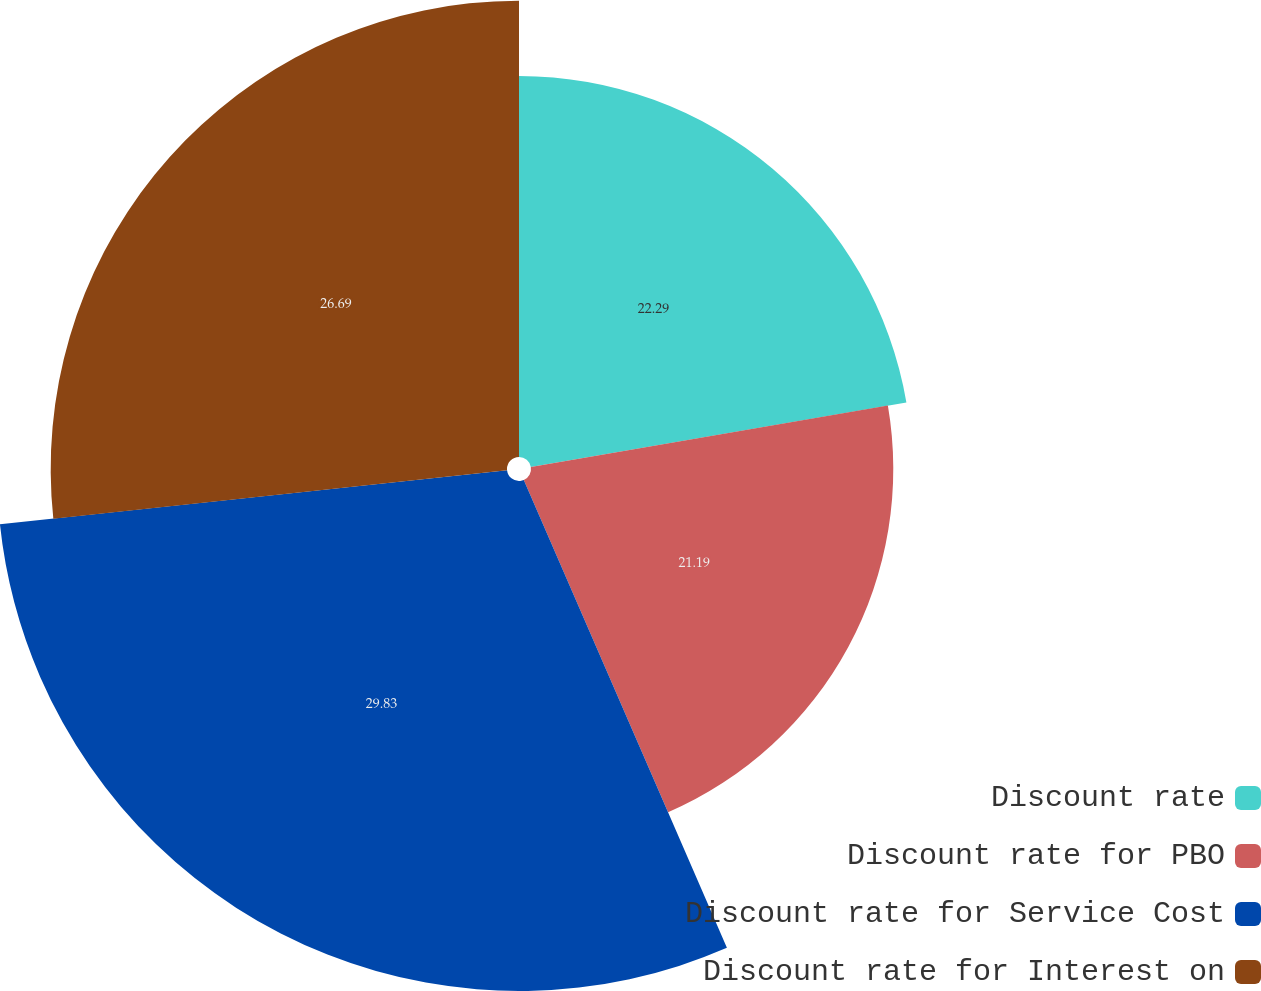Convert chart. <chart><loc_0><loc_0><loc_500><loc_500><pie_chart><fcel>Discount rate<fcel>Discount rate for PBO<fcel>Discount rate for Service Cost<fcel>Discount rate for Interest on<nl><fcel>22.29%<fcel>21.19%<fcel>29.83%<fcel>26.69%<nl></chart> 